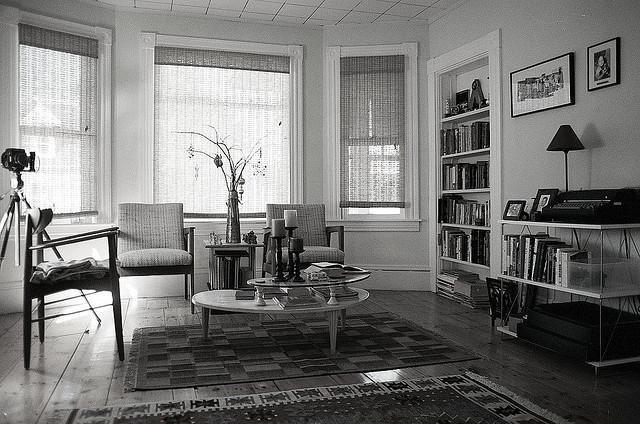What is the camera on the left setup on? Please explain your reasoning. tripod. A room in a home has a camera in the corner on a stand with three legs. 